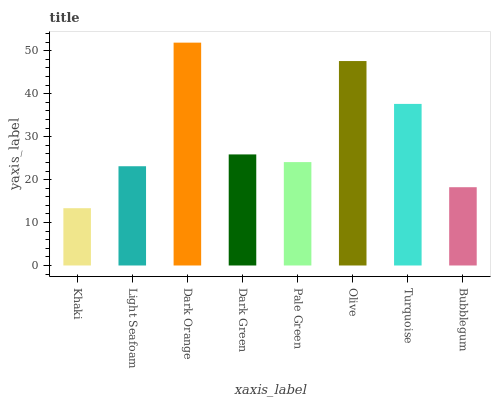Is Khaki the minimum?
Answer yes or no. Yes. Is Dark Orange the maximum?
Answer yes or no. Yes. Is Light Seafoam the minimum?
Answer yes or no. No. Is Light Seafoam the maximum?
Answer yes or no. No. Is Light Seafoam greater than Khaki?
Answer yes or no. Yes. Is Khaki less than Light Seafoam?
Answer yes or no. Yes. Is Khaki greater than Light Seafoam?
Answer yes or no. No. Is Light Seafoam less than Khaki?
Answer yes or no. No. Is Dark Green the high median?
Answer yes or no. Yes. Is Pale Green the low median?
Answer yes or no. Yes. Is Turquoise the high median?
Answer yes or no. No. Is Olive the low median?
Answer yes or no. No. 